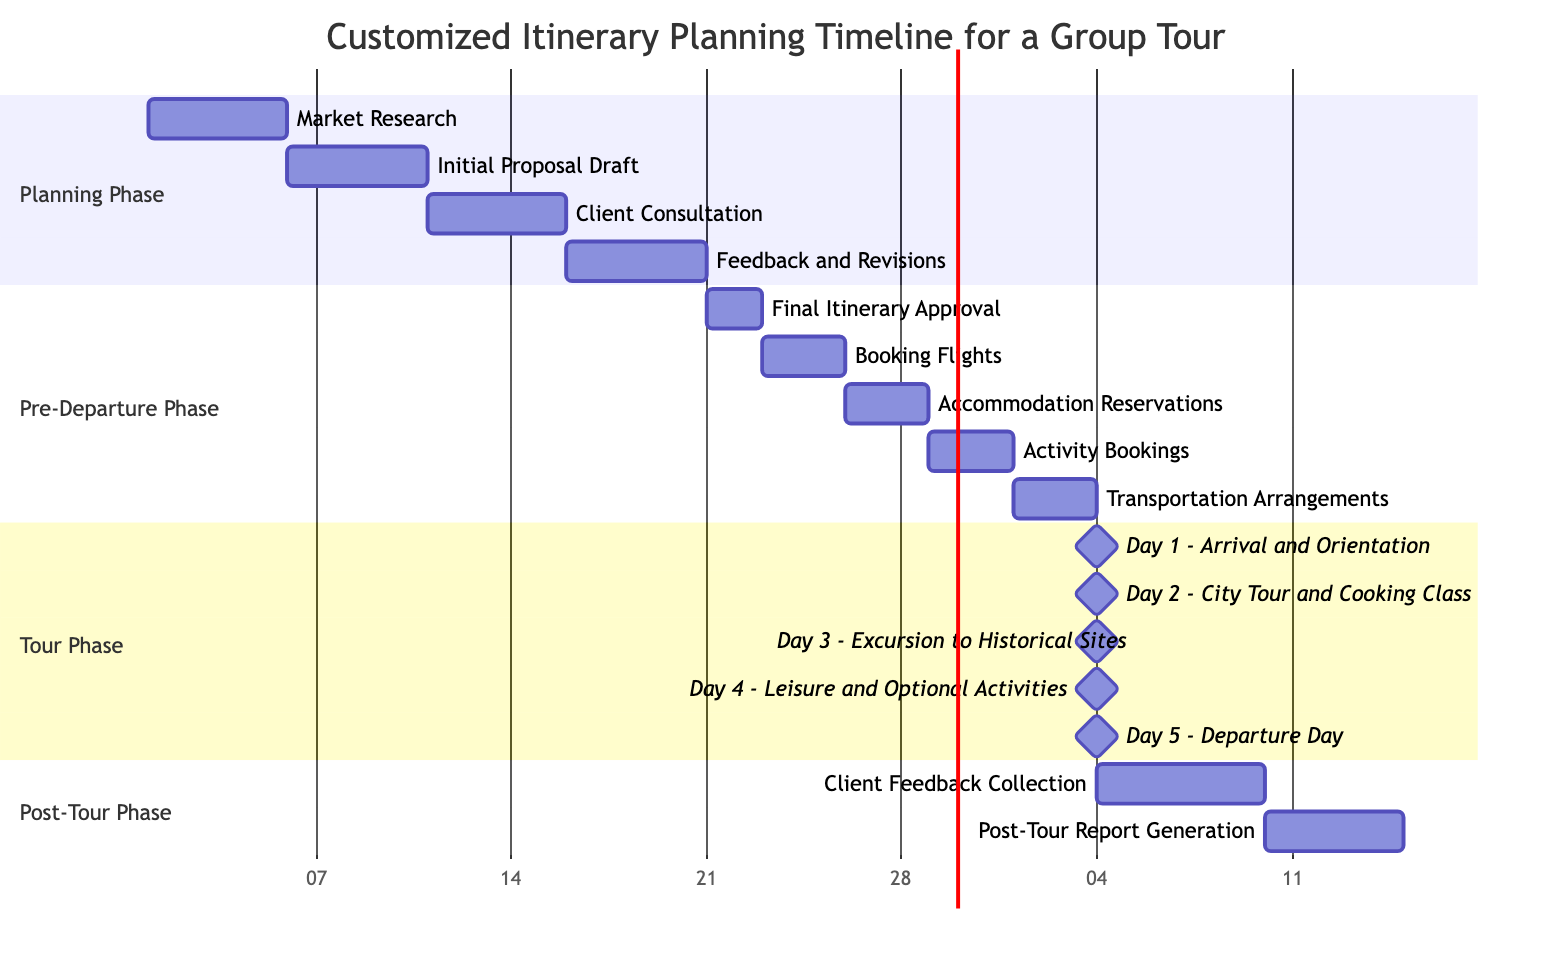What is the duration of the Market Research phase? The Market Research phase starts on day 1 and ends on day 5, giving it a total duration of 5 days.
Answer: 5 days What follows the Client Consultation phase? The Client Consultation phase (days 11-15) is directly followed by the Feedback and Revisions phase (days 16-20).
Answer: Feedback and Revisions How many days are allocated for Booking Flights? The Booking Flights phase is scheduled from days 23 to 25, which involves a duration of 3 days.
Answer: 3 days What is the total duration of the Tour Phase? The Tour Phase consists of 5 days of activities (from days 35 to 39) where each day is a distinct milestone.
Answer: 5 days Which phase comes after the Pre-Departure Phase? The Post-Tour Phase immediately follows the Pre-Departure Phase after the Departure Day.
Answer: Post-Tour Phase How many milestones are present in the Tour Phase? The Tour Phase includes 5 milestones, each representing a distinct day of activities.
Answer: 5 milestones What is the relationship between Accommodation Reservations and Transportation Arrangements? Accommodation Reservations must be completed before Transportation Arrangements can begin, demonstrating a sequential dependency.
Answer: Sequential dependency What is the first activity in the Post-Tour Phase? The first activity in the Post-Tour Phase is the Client Feedback Collection, taking place on days 40 to 45.
Answer: Client Feedback Collection How long does the entire Customized Itinerary Planning take from start to end? The planning begins on day 1 with Market Research and ends on day 50 with Post-Tour Report Generation, totaling 50 days.
Answer: 50 days 